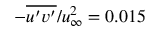<formula> <loc_0><loc_0><loc_500><loc_500>- \overline { { u ^ { \prime } v ^ { \prime } } } / u _ { \infty } ^ { 2 } = 0 . 0 1 5</formula> 